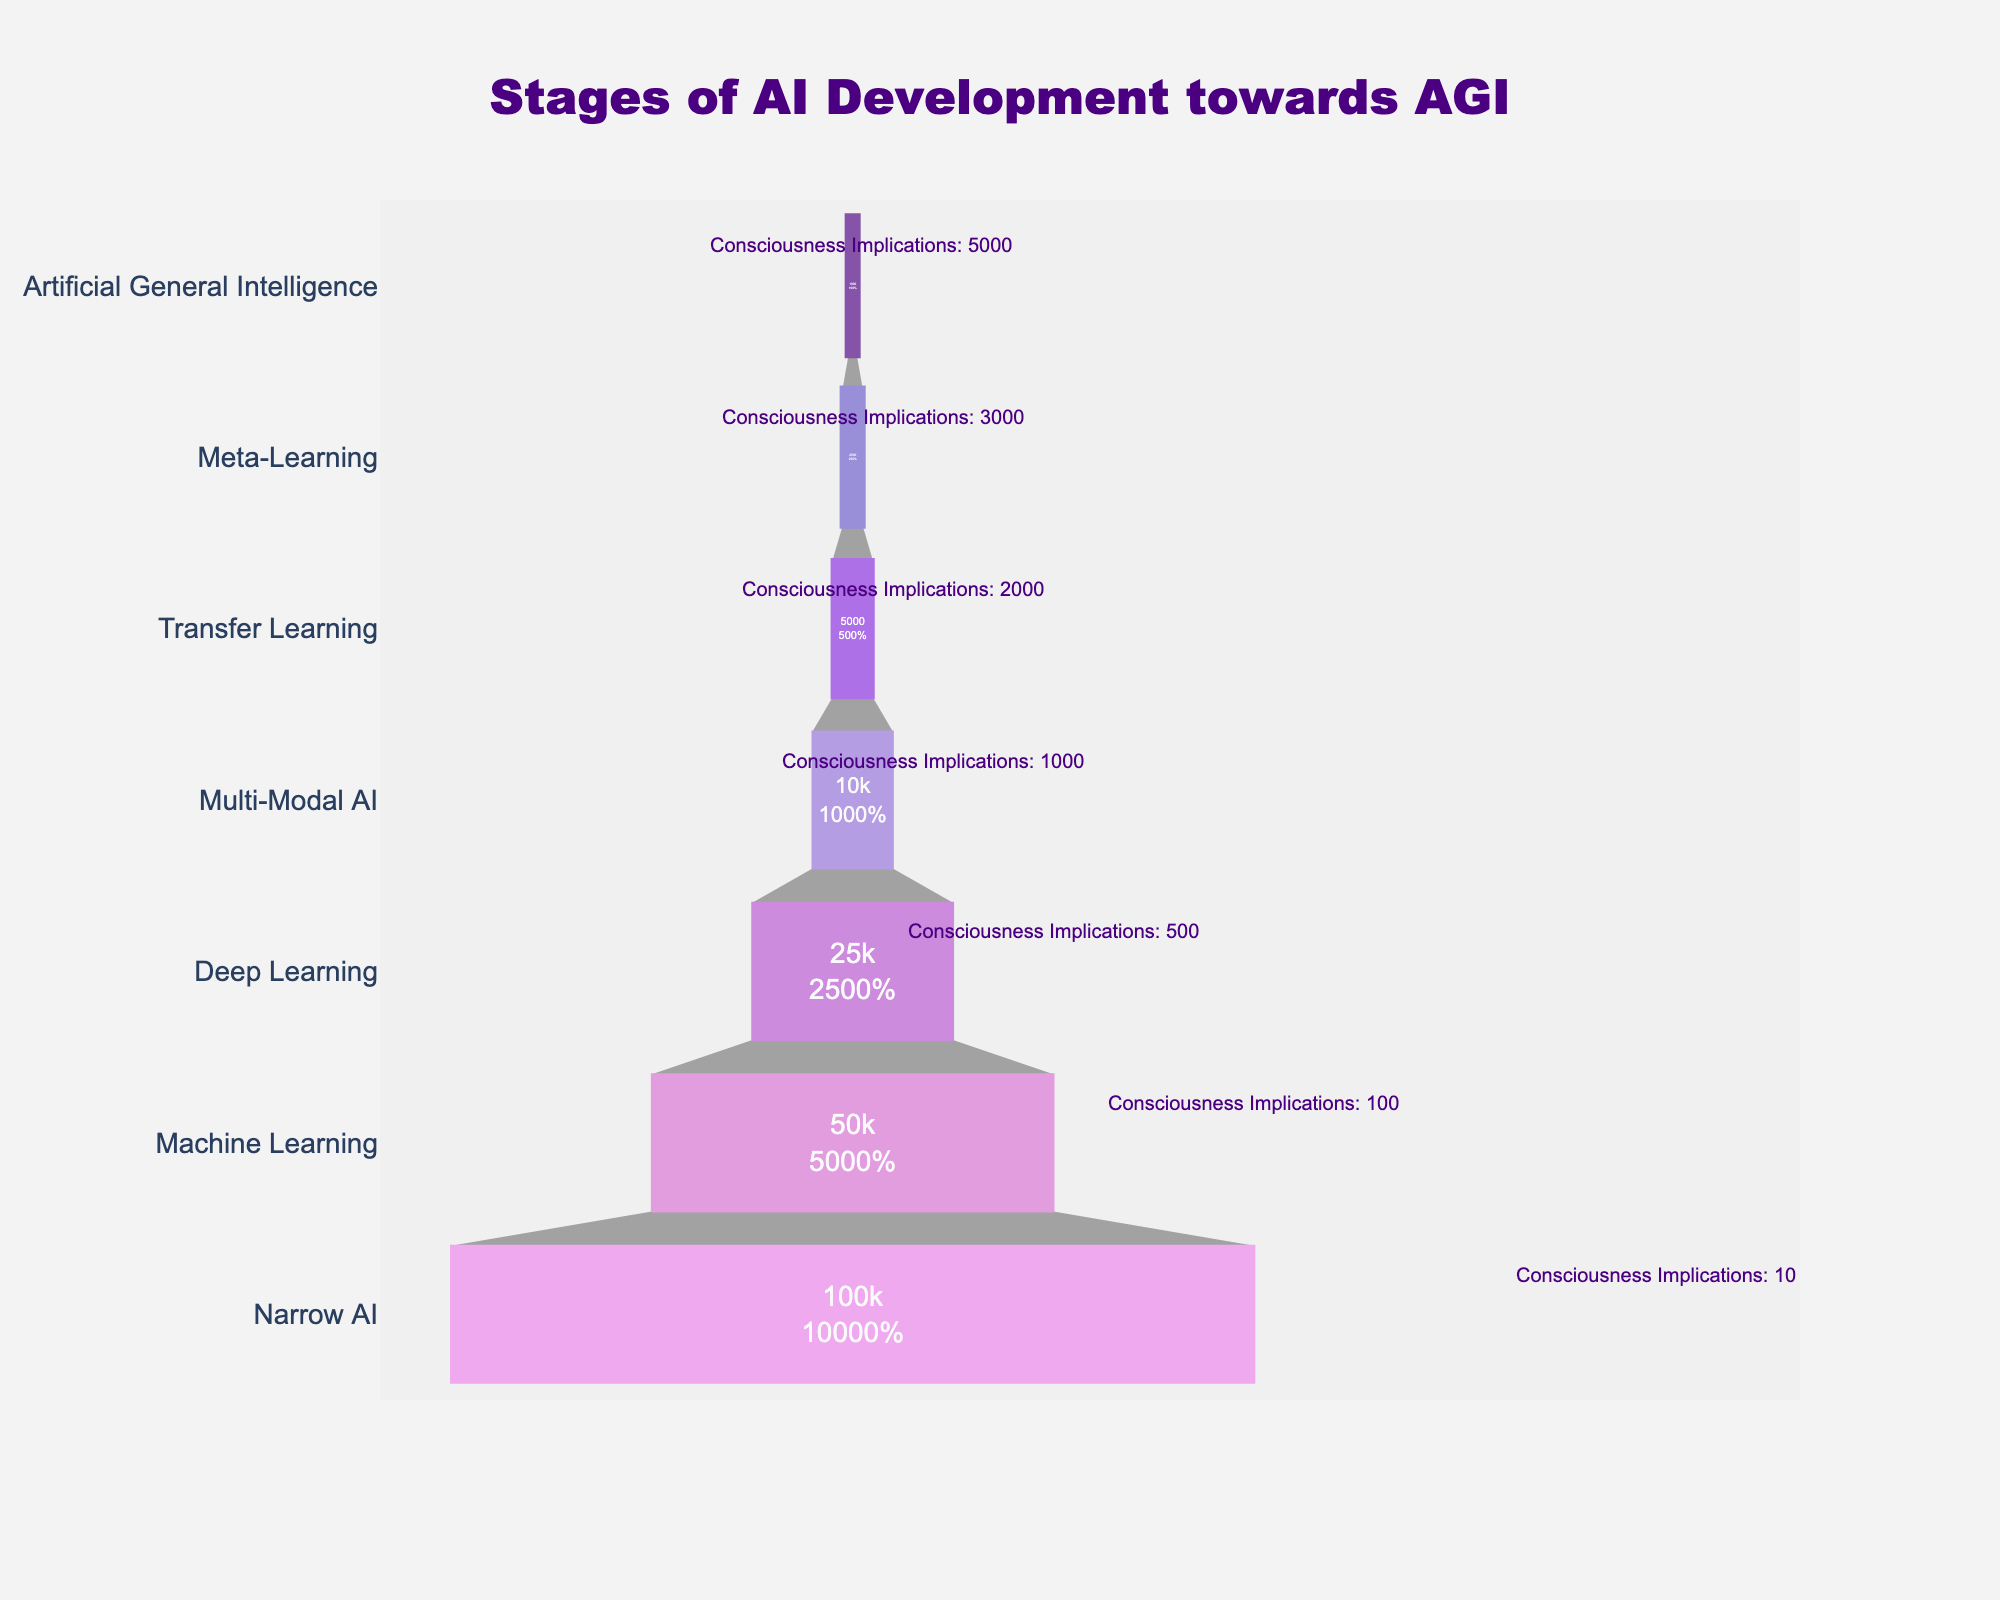What is the title of the funnel chart? The title is typically found at the top of the chart. In this funnel chart, the title is "Stages of AI Development towards AGI".
Answer: Stages of AI Development towards AGI Which stage has the largest number of Potential AGI Systems? The chart is structured from the bottom to the top, so the stage with the largest number of Potential AGI Systems will be at the widest part.
Answer: Narrow AI What is the total number of Potential AGI Systems for the stages above Machine Learning? To find this, sum the Potential AGI Systems for all stages above Machine Learning: Deep Learning (25000) + Multi-Modal AI (10000) + Transfer Learning (5000) + Meta-Learning (2500) + Artificial General Intelligence (1000). 25000 + 10000 + 5000 + 2500 + 1000 = 43500.
Answer: 43500 Which stage has the highest Consciousness Implications? The data provides the number of Consciousness Implications for each stage. By comparing these, the stage with the highest Consciousness Implications is identified.
Answer: Artificial General Intelligence How many stages have Consciousness Implications greater than 1000? Check the Consciousness Implications for each stage and count how many have values greater than 1000. Multi-Modal AI (1000), Transfer Learning (2000), Meta-Learning (3000), Artificial General Intelligence (5000). So there are 3 stages.
Answer: 3 stages What is the ratio of Potential AGI Systems between Narrow AI and Artificial General Intelligence? The Potential AGI Systems for Narrow AI is 100000 and for Artificial General Intelligence is 1000. The ratio is found by dividing 100000 by 1000.
Answer: 100:1 How do the stages of AI development progress in terms of Potential AGI Systems? This question requires observing the funnel's width at different stages. Each subsequent stage typically has fewer Potential AGI Systems than the previous one. Starting from Narrow AI with 100000 systems, the numbers decrease through each stage.
Answer: Decreasing Compare the number of Potential AGI Systems between Machine Learning and Meta-Learning. Check the values of Machine Learning (50000) and Meta-Learning (2500) and compare them. Machine Learning has significantly more.
Answer: Machine Learning has more What is the percentage decrease in Potential AGI Systems from Machine Learning to Deep Learning? Calculate the difference between Machine Learning (50000) and Deep Learning (25000), then divide by Machine Learning (50000), and multiply by 100 percent. (50000 - 25000) / 50000 * 100 = 50%.
Answer: 50% What does the funnel shape signify in this chart? The decreasing width of the funnel from top to bottom signifies that as the stages progress towards AGI, the number of Potential AGI Systems decreases, but the Consciousness Implications tend to increase.
Answer: Decrease in Potential AGI Systems, increase in Consciousness Implications 